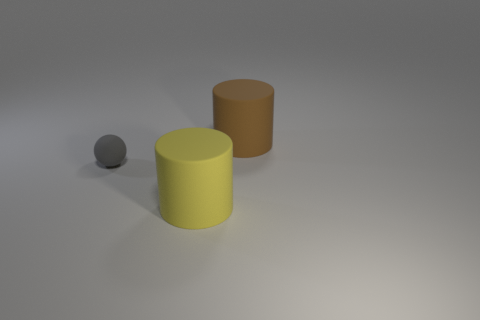Add 2 small purple metallic spheres. How many objects exist? 5 Subtract all cylinders. How many objects are left? 1 Add 2 matte cylinders. How many matte cylinders are left? 4 Add 2 small brown shiny blocks. How many small brown shiny blocks exist? 2 Subtract 0 blue cylinders. How many objects are left? 3 Subtract 1 spheres. How many spheres are left? 0 Subtract all yellow balls. Subtract all brown cylinders. How many balls are left? 1 Subtract all brown objects. Subtract all tiny cyan rubber things. How many objects are left? 2 